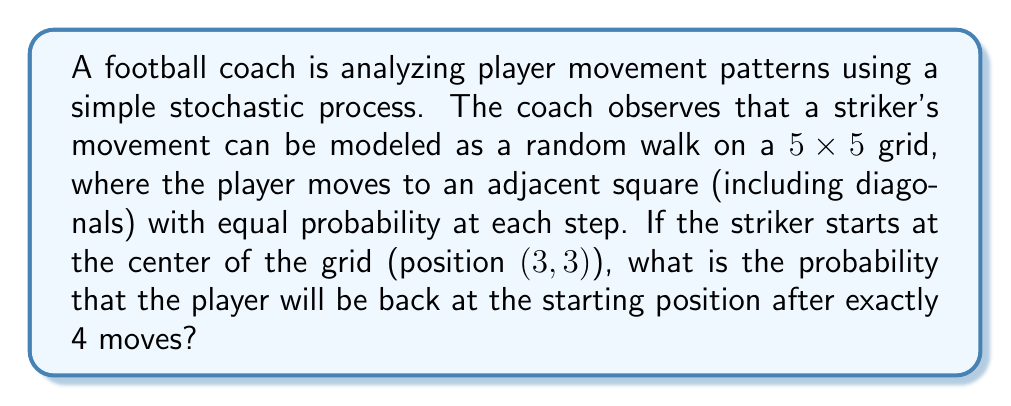Can you solve this math problem? Let's approach this step-by-step:

1) First, we need to understand the possible movements. From any given position, the player can move to 8 adjacent squares (including diagonals), unless they're at the edge of the grid.

2) To return to the starting position after 4 moves, the player must make moves that cancel each other out. For example, moving up then down, or moving diagonally up-right then down-left.

3) We can count the number of ways to return to the starting position in 4 moves:
   - 2 steps in one direction, 2 steps back: $\binom{4}{2} \cdot 4 = 24$ ways
   - 1 step in each of 4 directions that cancel out: $4! = 24$ ways

4) So there are 48 total ways to return to the starting position in 4 moves.

5) Now, we need to calculate the total number of possible 4-move sequences:
   - For each move, there are 8 possible directions
   - Total number of 4-move sequences: $8^4 = 4096$

6) The probability is thus:

   $$P(\text{return to start}) = \frac{\text{favorable outcomes}}{\text{total outcomes}} = \frac{48}{4096} = \frac{3}{256} \approx 0.01171875$$
Answer: $\frac{3}{256}$ 